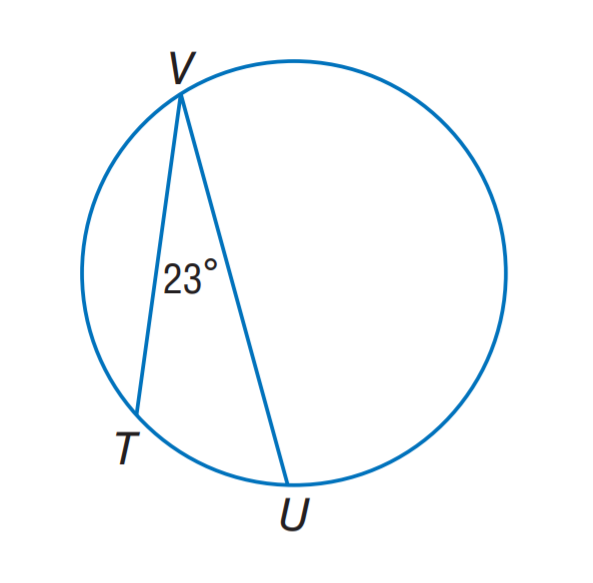Question: Find m \widehat T U.
Choices:
A. 11.5
B. 23
C. 46
D. 67
Answer with the letter. Answer: C 